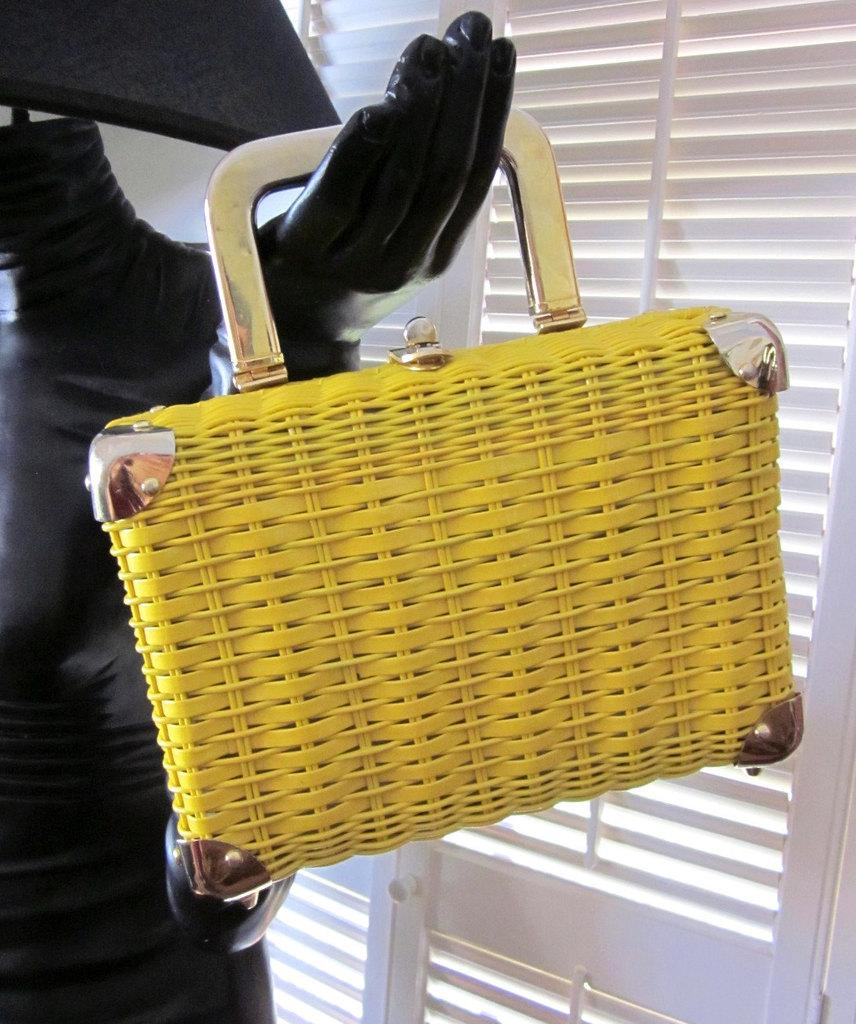What color is the handbag in the image? The handbag in the image is yellow. Who is holding the handbag in the image? The handbag is in a mannequin's hand. What can be seen in the background of the image? There are window blinds in the background of the image. How many sisters are depicted in the image? There are no sisters depicted in the image; it features a mannequin holding a handbag. What type of amusement can be seen in the image? There is no amusement present in the image; it features a mannequin holding a handbag and window blinds in the background. 